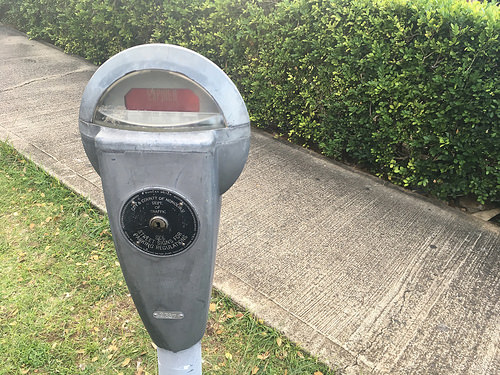<image>
Is the meter above the grass? Yes. The meter is positioned above the grass in the vertical space, higher up in the scene. 